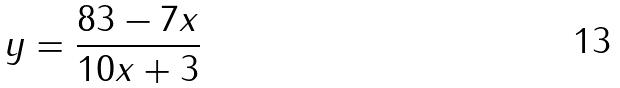Convert formula to latex. <formula><loc_0><loc_0><loc_500><loc_500>y = \frac { 8 3 - 7 x } { 1 0 x + 3 }</formula> 